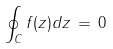<formula> <loc_0><loc_0><loc_500><loc_500>\oint _ { C } f ( z ) d z \, = \, 0</formula> 